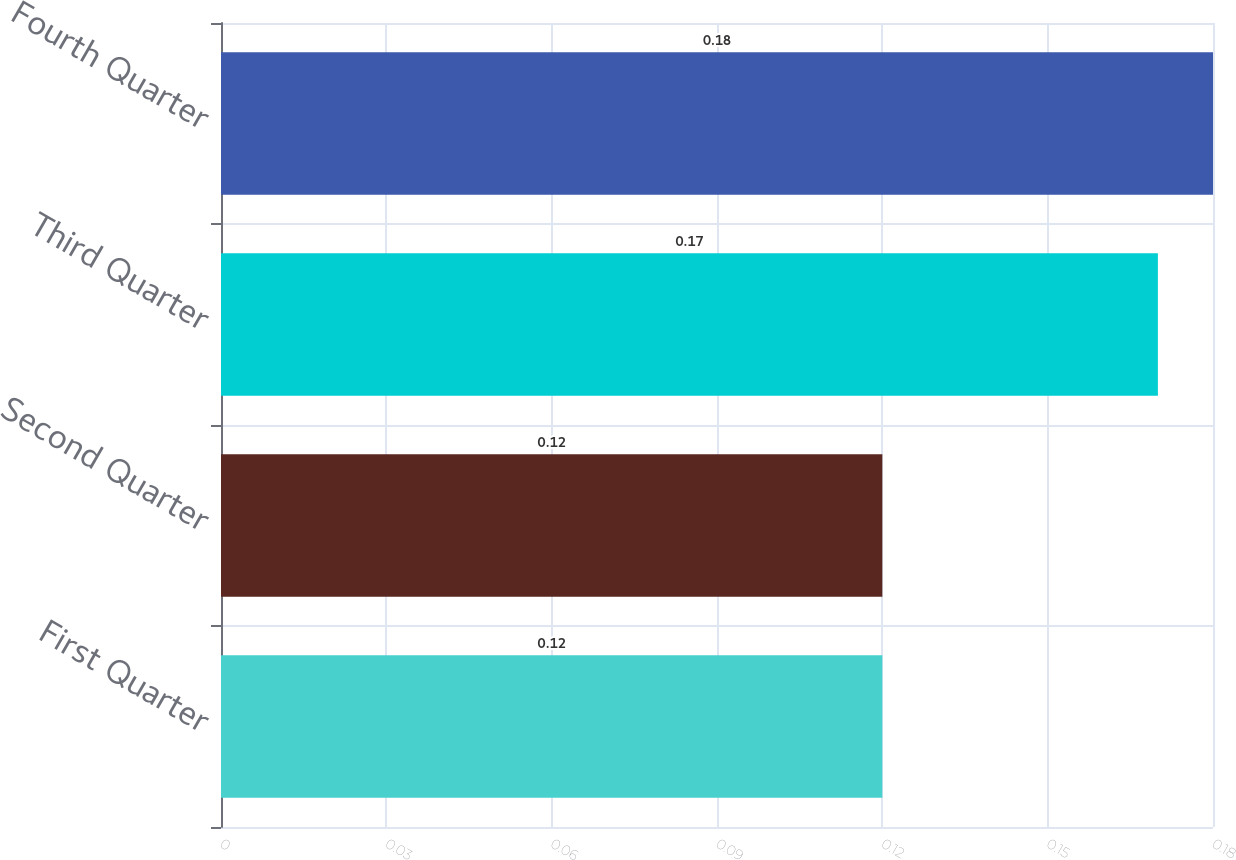Convert chart to OTSL. <chart><loc_0><loc_0><loc_500><loc_500><bar_chart><fcel>First Quarter<fcel>Second Quarter<fcel>Third Quarter<fcel>Fourth Quarter<nl><fcel>0.12<fcel>0.12<fcel>0.17<fcel>0.18<nl></chart> 